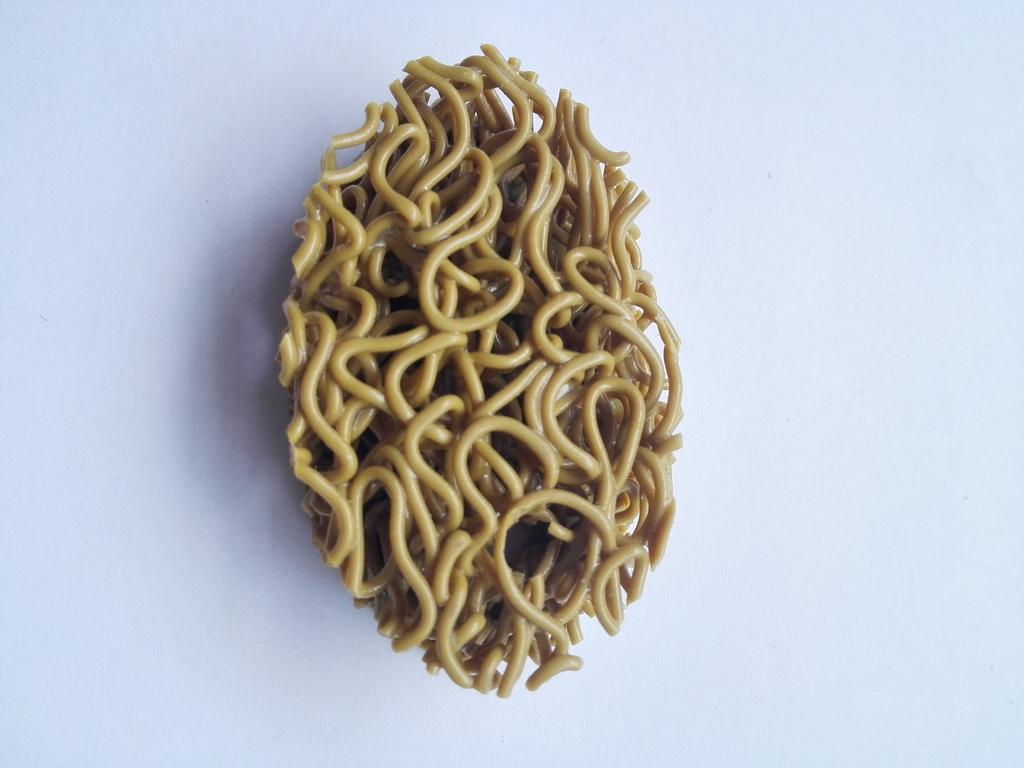What type of food is visible in the image? There are noodles in the image. What type of canvas is being used to display the noodles in the image? There is no canvas present in the image; the noodles are likely on a plate or in a bowl. 